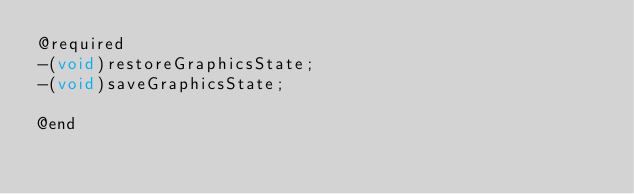<code> <loc_0><loc_0><loc_500><loc_500><_C_>@required
-(void)restoreGraphicsState;
-(void)saveGraphicsState;

@end

</code> 